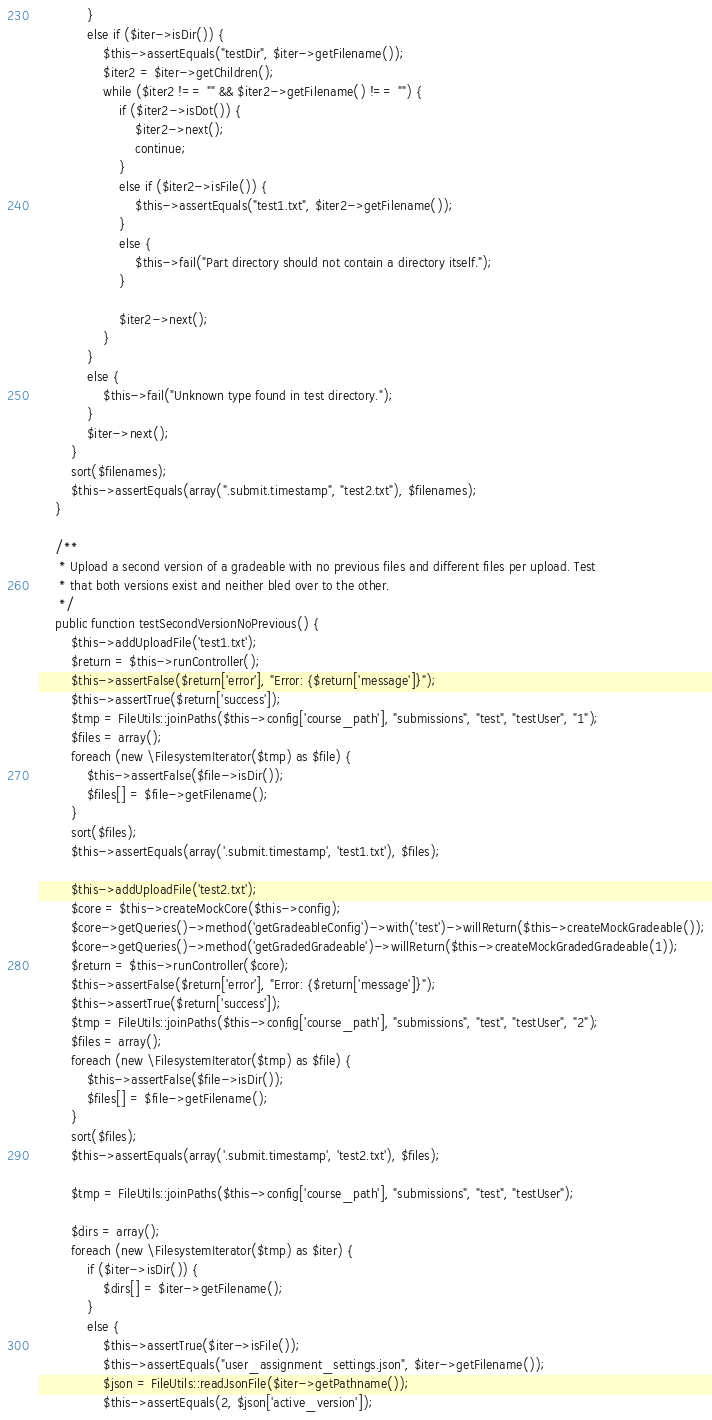Convert code to text. <code><loc_0><loc_0><loc_500><loc_500><_PHP_>            }
            else if ($iter->isDir()) {
                $this->assertEquals("testDir", $iter->getFilename());
                $iter2 = $iter->getChildren();
                while ($iter2 !== "" && $iter2->getFilename() !== "") {
                    if ($iter2->isDot()) {
                        $iter2->next();
                        continue;
                    }
                    else if ($iter2->isFile()) {
                        $this->assertEquals("test1.txt", $iter2->getFilename());
                    }
                    else {
                        $this->fail("Part directory should not contain a directory itself.");
                    }

                    $iter2->next();
                }
            }
            else {
                $this->fail("Unknown type found in test directory.");
            }
            $iter->next();
        }
        sort($filenames);
        $this->assertEquals(array(".submit.timestamp", "test2.txt"), $filenames);
    }

    /**
     * Upload a second version of a gradeable with no previous files and different files per upload. Test
     * that both versions exist and neither bled over to the other.
     */
    public function testSecondVersionNoPrevious() {
        $this->addUploadFile('test1.txt');
        $return = $this->runController();
        $this->assertFalse($return['error'], "Error: {$return['message']}");
        $this->assertTrue($return['success']);
        $tmp = FileUtils::joinPaths($this->config['course_path'], "submissions", "test", "testUser", "1");
        $files = array();
        foreach (new \FilesystemIterator($tmp) as $file) {
            $this->assertFalse($file->isDir());
            $files[] = $file->getFilename();
        }
        sort($files);
        $this->assertEquals(array('.submit.timestamp', 'test1.txt'), $files);

        $this->addUploadFile('test2.txt');
        $core = $this->createMockCore($this->config);
        $core->getQueries()->method('getGradeableConfig')->with('test')->willReturn($this->createMockGradeable());
        $core->getQueries()->method('getGradedGradeable')->willReturn($this->createMockGradedGradeable(1));
        $return = $this->runController($core);
        $this->assertFalse($return['error'], "Error: {$return['message']}");
        $this->assertTrue($return['success']);
        $tmp = FileUtils::joinPaths($this->config['course_path'], "submissions", "test", "testUser", "2");
        $files = array();
        foreach (new \FilesystemIterator($tmp) as $file) {
            $this->assertFalse($file->isDir());
            $files[] = $file->getFilename();
        }
        sort($files);
        $this->assertEquals(array('.submit.timestamp', 'test2.txt'), $files);

        $tmp = FileUtils::joinPaths($this->config['course_path'], "submissions", "test", "testUser");

        $dirs = array();
        foreach (new \FilesystemIterator($tmp) as $iter) {
            if ($iter->isDir()) {
                $dirs[] = $iter->getFilename();
            }
            else {
                $this->assertTrue($iter->isFile());
                $this->assertEquals("user_assignment_settings.json", $iter->getFilename());
                $json = FileUtils::readJsonFile($iter->getPathname());
                $this->assertEquals(2, $json['active_version']);</code> 